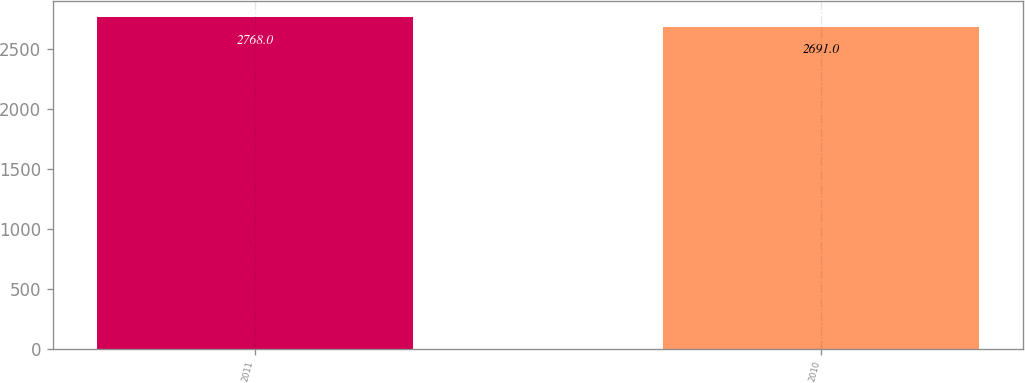Convert chart to OTSL. <chart><loc_0><loc_0><loc_500><loc_500><bar_chart><fcel>2011<fcel>2010<nl><fcel>2768<fcel>2691<nl></chart> 